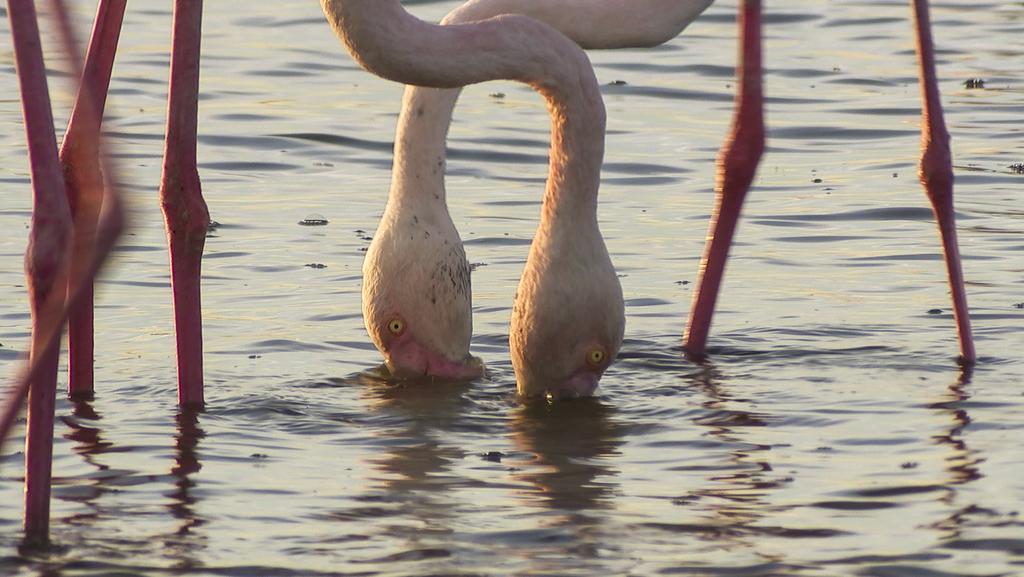How would you summarize this image in a sentence or two? In the foreground of this image, it seems like cranes like birds in the water. 